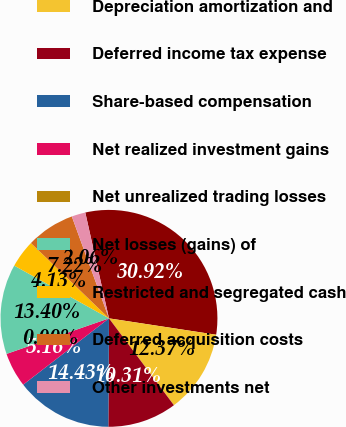<chart> <loc_0><loc_0><loc_500><loc_500><pie_chart><fcel>Net income<fcel>Depreciation amortization and<fcel>Deferred income tax expense<fcel>Share-based compensation<fcel>Net realized investment gains<fcel>Net unrealized trading losses<fcel>Net losses (gains) of<fcel>Restricted and segregated cash<fcel>Deferred acquisition costs<fcel>Other investments net<nl><fcel>30.92%<fcel>12.37%<fcel>10.31%<fcel>14.43%<fcel>5.16%<fcel>0.0%<fcel>13.4%<fcel>4.13%<fcel>7.22%<fcel>2.06%<nl></chart> 